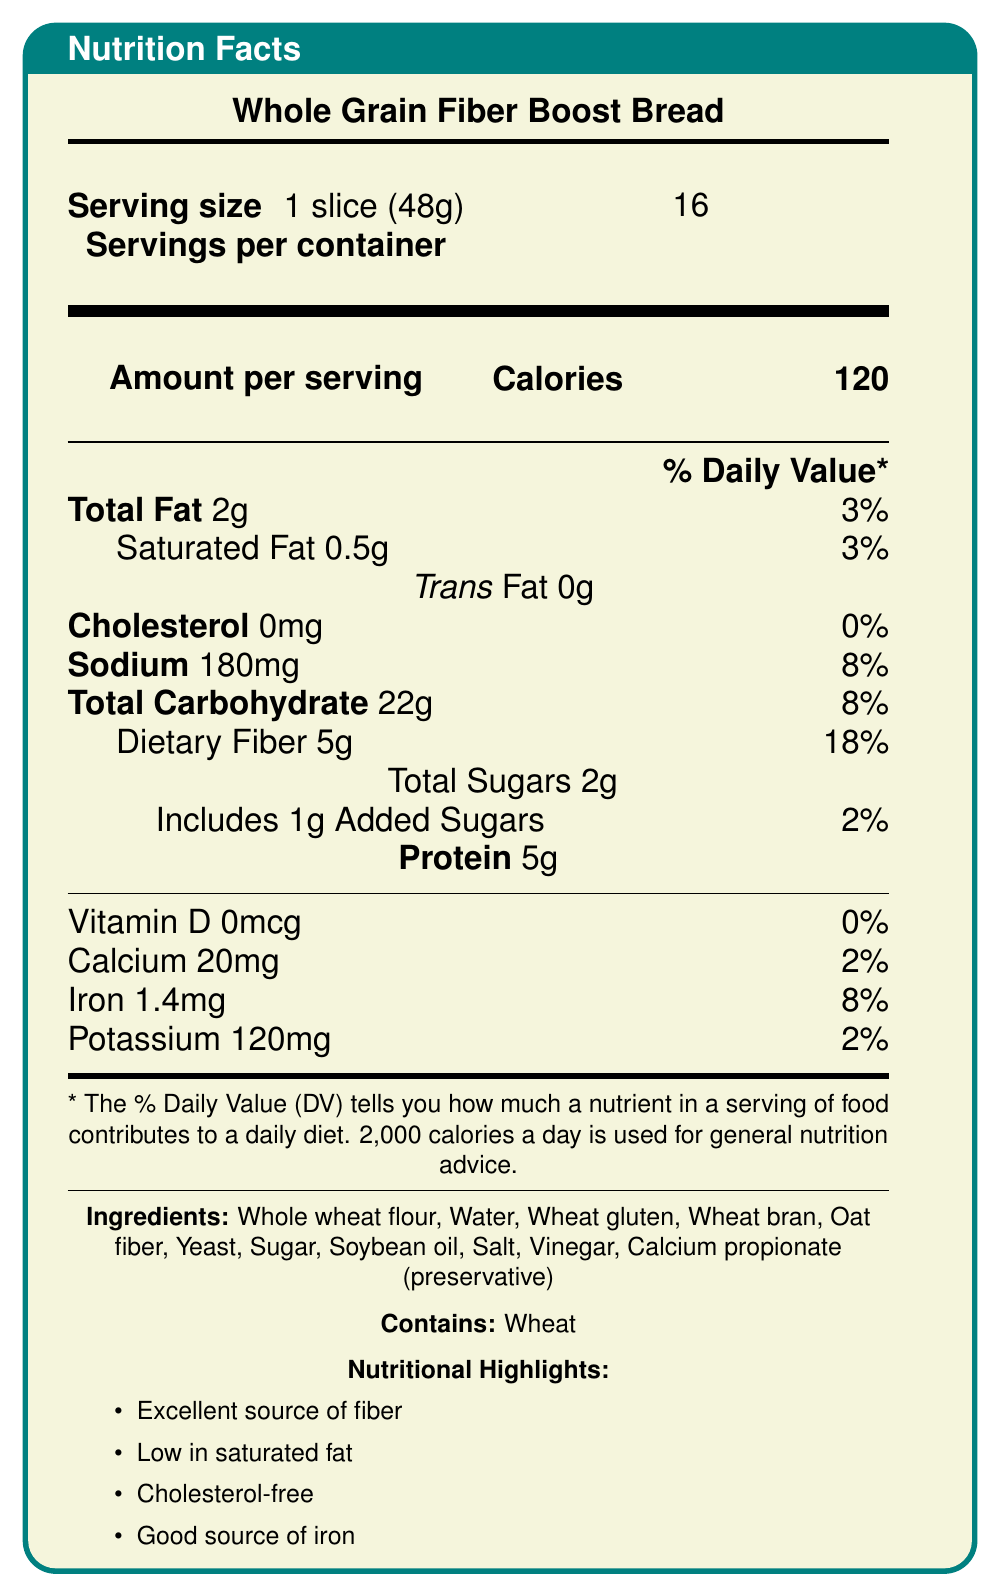what is the serving size? The serving size is clearly labeled as 1 slice (48g) in the document.
Answer: 1 slice (48g) how many calories are in one serving? The document specifies that there are 120 calories per serving.
Answer: 120 calories what is the total fat content per serving? The total fat content per serving is listed as 2g.
Answer: 2g how many grams of dietary fiber are in each serving? The document states that there are 5 grams of dietary fiber per serving.
Answer: 5g which ingredient is used as a preservative? Calcium propionate is listed as the preservative in the ingredients section of the document.
Answer: Calcium propionate what percentage of the daily value for iron does one serving provide? A. 2% B. 8% C. 18% The document shows that one serving provides 8% of the daily value for iron.
Answer: B. 8% which nutrient has a daily value percentage of 0%? A. Vitamin D B. Iron C. Sodium The daily value percentage for Vitamin D is listed as 0%.
Answer: A. Vitamin D is this bread cholesterol-free? The cholesterol content is 0mg, which means it is cholesterol-free.
Answer: Yes does the bread contain any allergens? The allergen warning clearly states that the bread contains wheat.
Answer: Yes, it contains wheat. what is the main idea of this document? The document summarizes the nutritional content and benefits of the bread, ingredients, and suggests community outreach programs related to nutrition education.
Answer: The document provides detailed nutrition facts for Whole Grain Fiber Boost Bread, including serving size, calories, fat content, vitamins, and ingredients, highlights its nutritional benefits, and offers program ideas for community outreach. how much protein is in one serving of the bread? The protein content per serving is listed as 5g.
Answer: 5g can the amount of added sugars per serving be determined? The document lists the amount of added sugars as 1g.
Answer: Yes, it is 1g. is calcium listed as an essential mineral in the bread, and how much does it contain? Calcium is listed among the nutrients, with 20mg per serving, contributing to 2% of the daily value.
Answer: Yes, it contains 20mg, which is 2% of the daily value. does the bread contain any trans fat? The document specifies that there is 0g of trans fat in the bread.
Answer: No how many servings are in one container of Whole Grain Fiber Boost Bread? The document states that there are 16 servings per container.
Answer: 16 servings does the document explain how the percentage daily value is calculated? The document includes a note that the % Daily Value tells you how much a nutrient in a serving contributes to a daily diet based on 2,000 calories a day.
Answer: Yes what are some of the nutritional highlights of the bread? The document lists these as the main nutritional highlights in a separate section.
Answer: Excellent source of fiber, Low in saturated fat, Cholesterol-free, Good source of iron can we determine the exact amount of whole wheat flour used? The document lists whole wheat flour as an ingredient but does not specify the exact amount used.
Answer: Cannot be determined 